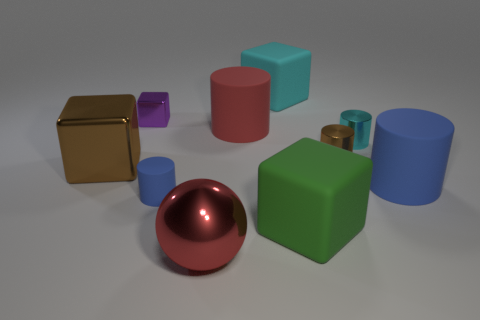Is there a cylinder that has the same material as the big green block?
Your response must be concise. Yes. What is the material of the other cylinder that is the same color as the small rubber cylinder?
Offer a very short reply. Rubber. Does the large cylinder that is right of the tiny cyan metal cylinder have the same material as the big block that is behind the cyan metal thing?
Your response must be concise. Yes. Are there more large red cylinders than blue cylinders?
Provide a succinct answer. No. There is a large matte block in front of the blue cylinder left of the matte object that is on the right side of the small cyan cylinder; what is its color?
Provide a short and direct response. Green. There is a large metal object that is in front of the large brown shiny cube; is its color the same as the big cylinder to the left of the green object?
Give a very brief answer. Yes. How many rubber cubes are in front of the brown metal thing to the right of the big shiny block?
Provide a succinct answer. 1. Are there any small red rubber blocks?
Your answer should be very brief. No. What number of other things are the same color as the metallic sphere?
Ensure brevity in your answer.  1. Is the number of large cyan rubber cubes less than the number of cyan matte balls?
Your answer should be very brief. No. 